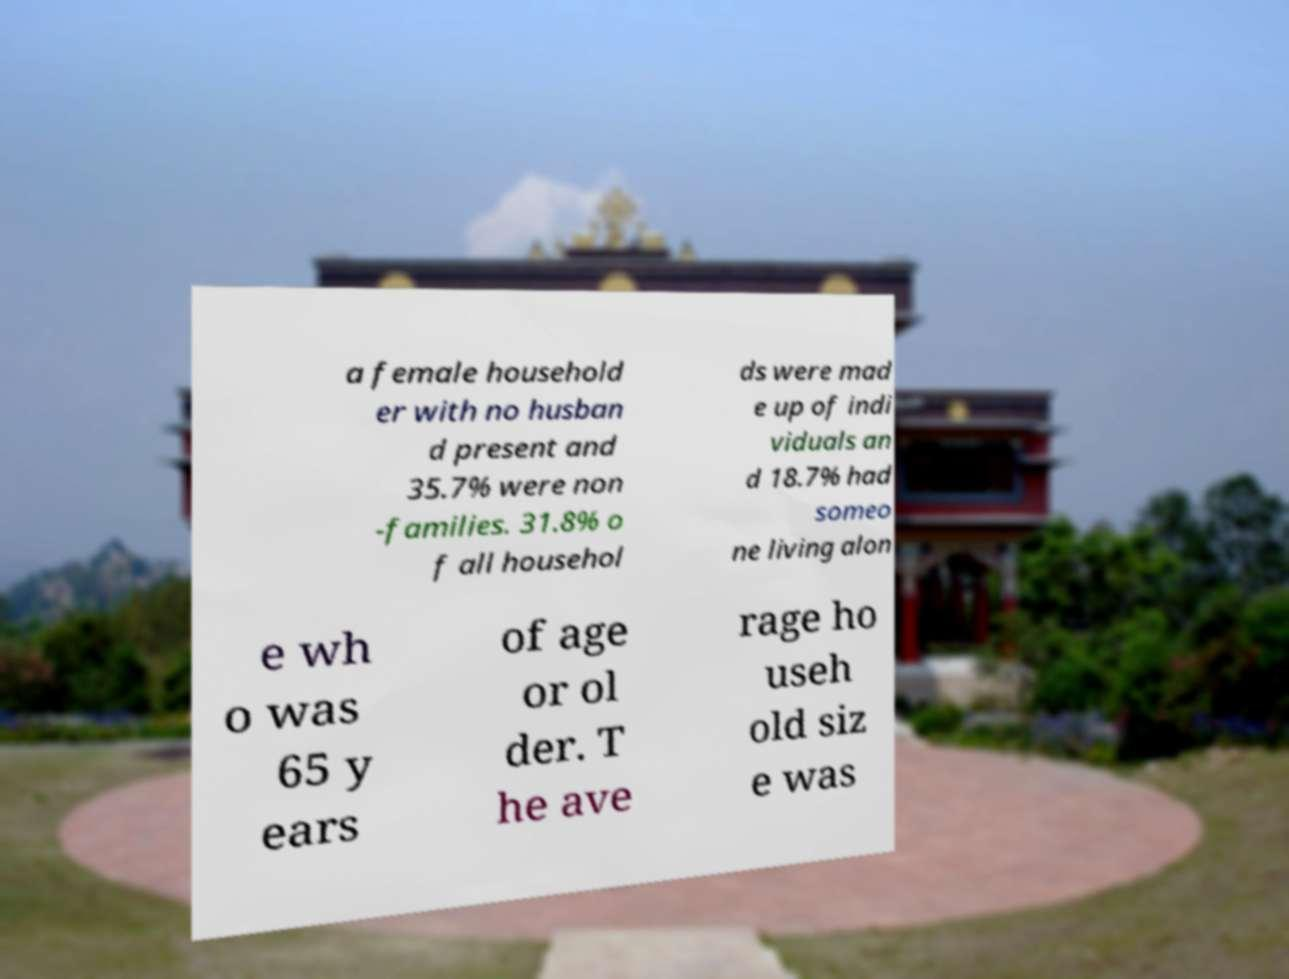There's text embedded in this image that I need extracted. Can you transcribe it verbatim? a female household er with no husban d present and 35.7% were non -families. 31.8% o f all househol ds were mad e up of indi viduals an d 18.7% had someo ne living alon e wh o was 65 y ears of age or ol der. T he ave rage ho useh old siz e was 